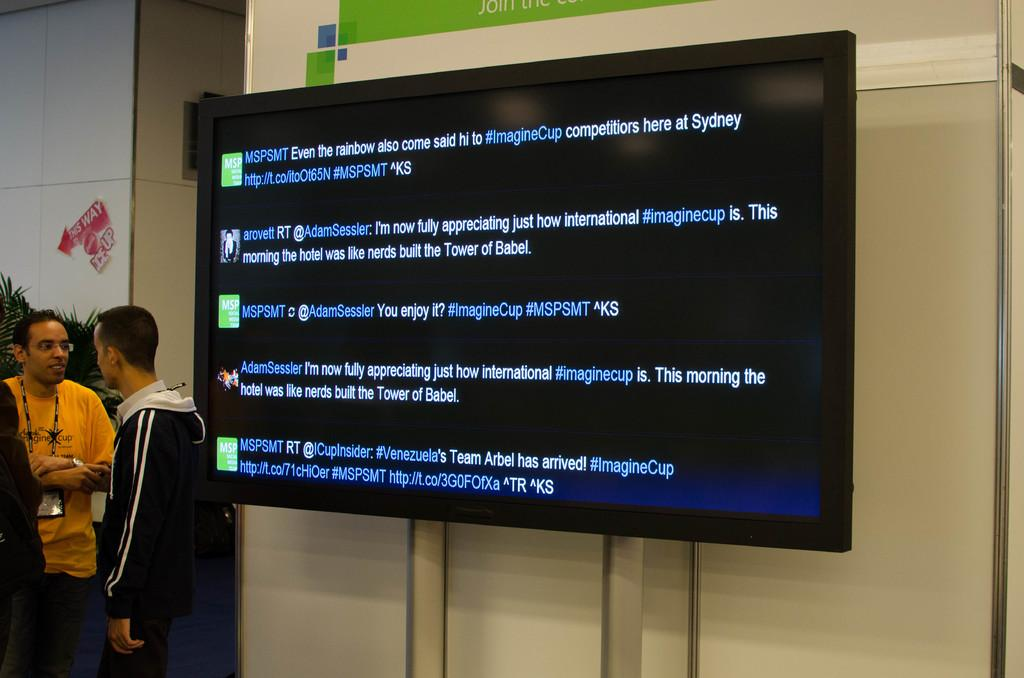What is displayed on the screen in the image? There is a screen with text in the image. Who or what can be seen in the image besides the screen? There are people in the image. What type of natural elements are present in the image? Leaves are present in the image. What else can be seen in the image besides the screen, people, and leaves? There are objects in the image. What type of setting is depicted in the background of the image? The background of the image includes walls. What type of vessel is being used by the people in the image? There is no vessel present in the image; it only shows a screen with text, people, leaves, objects, and walls in the background. 